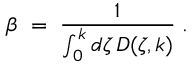<formula> <loc_0><loc_0><loc_500><loc_500>\beta \, = \, { \frac { 1 } { \int _ { 0 } ^ { k } d \zeta \, D ( \zeta , k ) } } \, .</formula> 